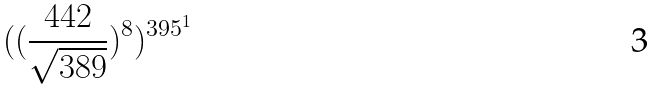Convert formula to latex. <formula><loc_0><loc_0><loc_500><loc_500>( ( \frac { 4 4 2 } { \sqrt { 3 8 9 } } ) ^ { 8 } ) ^ { 3 9 5 ^ { 1 } }</formula> 